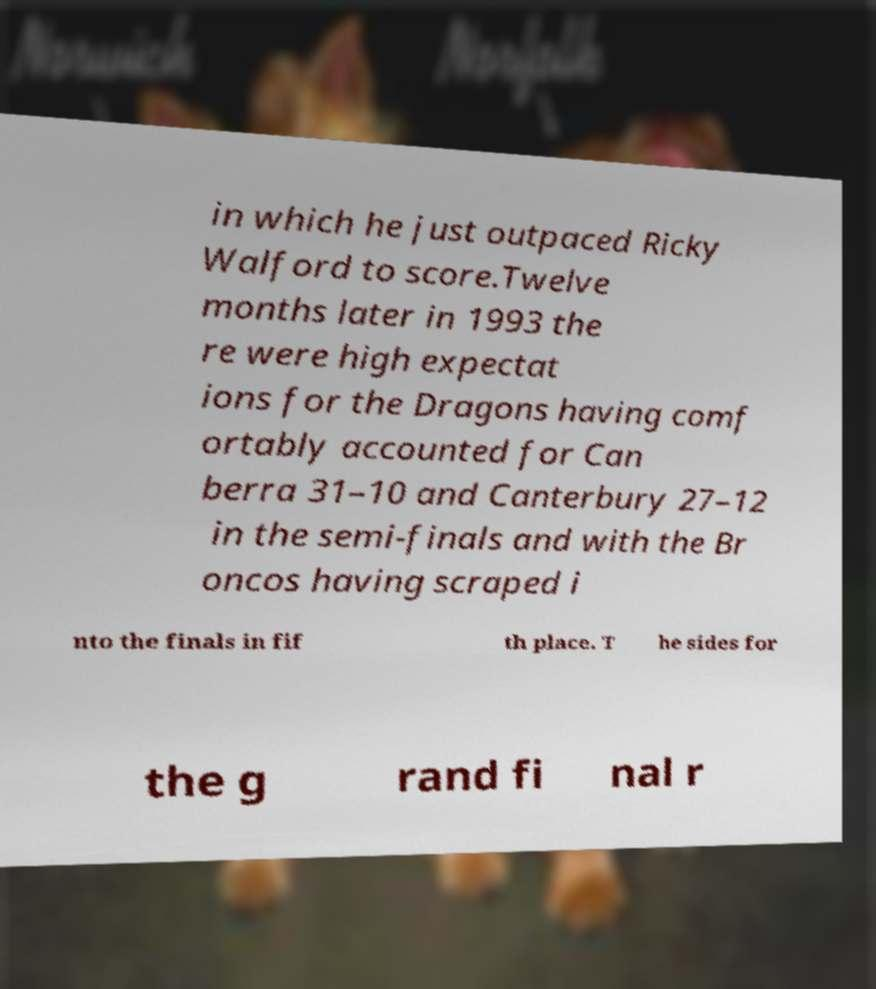For documentation purposes, I need the text within this image transcribed. Could you provide that? in which he just outpaced Ricky Walford to score.Twelve months later in 1993 the re were high expectat ions for the Dragons having comf ortably accounted for Can berra 31–10 and Canterbury 27–12 in the semi-finals and with the Br oncos having scraped i nto the finals in fif th place. T he sides for the g rand fi nal r 